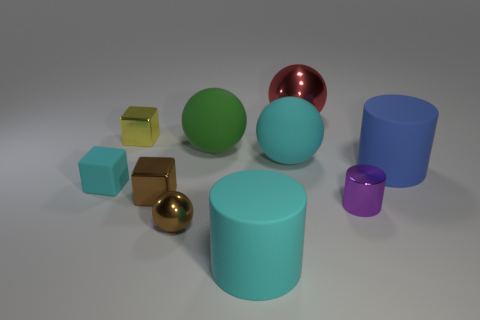Are there fewer small yellow metal blocks behind the red ball than green rubber things in front of the cyan ball?
Your answer should be compact. No. There is a block that is behind the brown cube and in front of the yellow metal cube; what size is it?
Keep it short and to the point. Small. Is there a large green rubber object that is right of the big cyan matte cylinder to the left of the tiny purple shiny cylinder that is to the right of the small yellow metal thing?
Your answer should be very brief. No. Are there any big cyan balls?
Offer a very short reply. Yes. Are there more cyan rubber things behind the matte block than small rubber blocks on the right side of the yellow object?
Offer a terse response. Yes. There is a brown cube that is the same material as the tiny purple object; what size is it?
Give a very brief answer. Small. There is a cyan thing behind the matte thing that is left of the metal sphere in front of the red metallic sphere; what is its size?
Your response must be concise. Large. The metallic ball behind the blue cylinder is what color?
Make the answer very short. Red. Are there more cyan matte things to the left of the brown metal sphere than cylinders?
Provide a short and direct response. No. Is the shape of the brown metal thing that is behind the tiny brown sphere the same as  the small matte object?
Offer a terse response. Yes. 